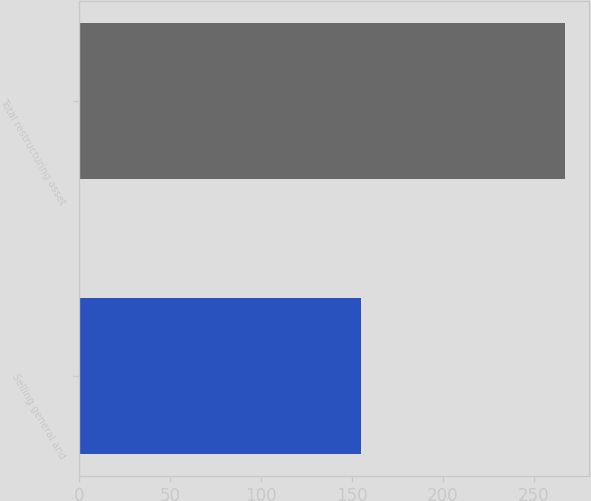<chart> <loc_0><loc_0><loc_500><loc_500><bar_chart><fcel>Selling general and<fcel>Total restructuring asset<nl><fcel>155<fcel>267<nl></chart> 